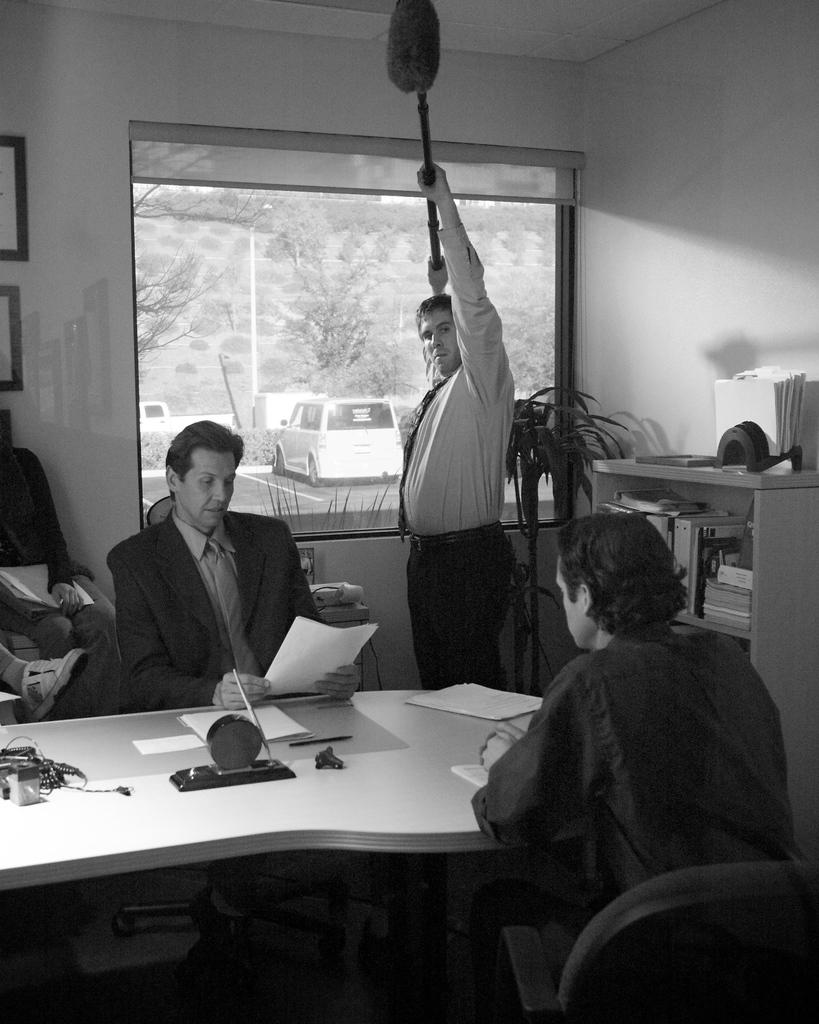How many people are sitting in the chair in the image? There are 2 persons sitting in a chair in the image. What is located near the chair? There is a table near the chair. What is the position of the third person in the image? There is another person standing in the image. What can be seen in the background of the image? In the background, there is a plant, a rack, books, a tree, and a car. What time of day is it, as indicated by the hour in the image? There is no hour or clock present in the image to indicate the time of day. What type of lunch is being served in the image? There is no lunch or food visible in the image. 